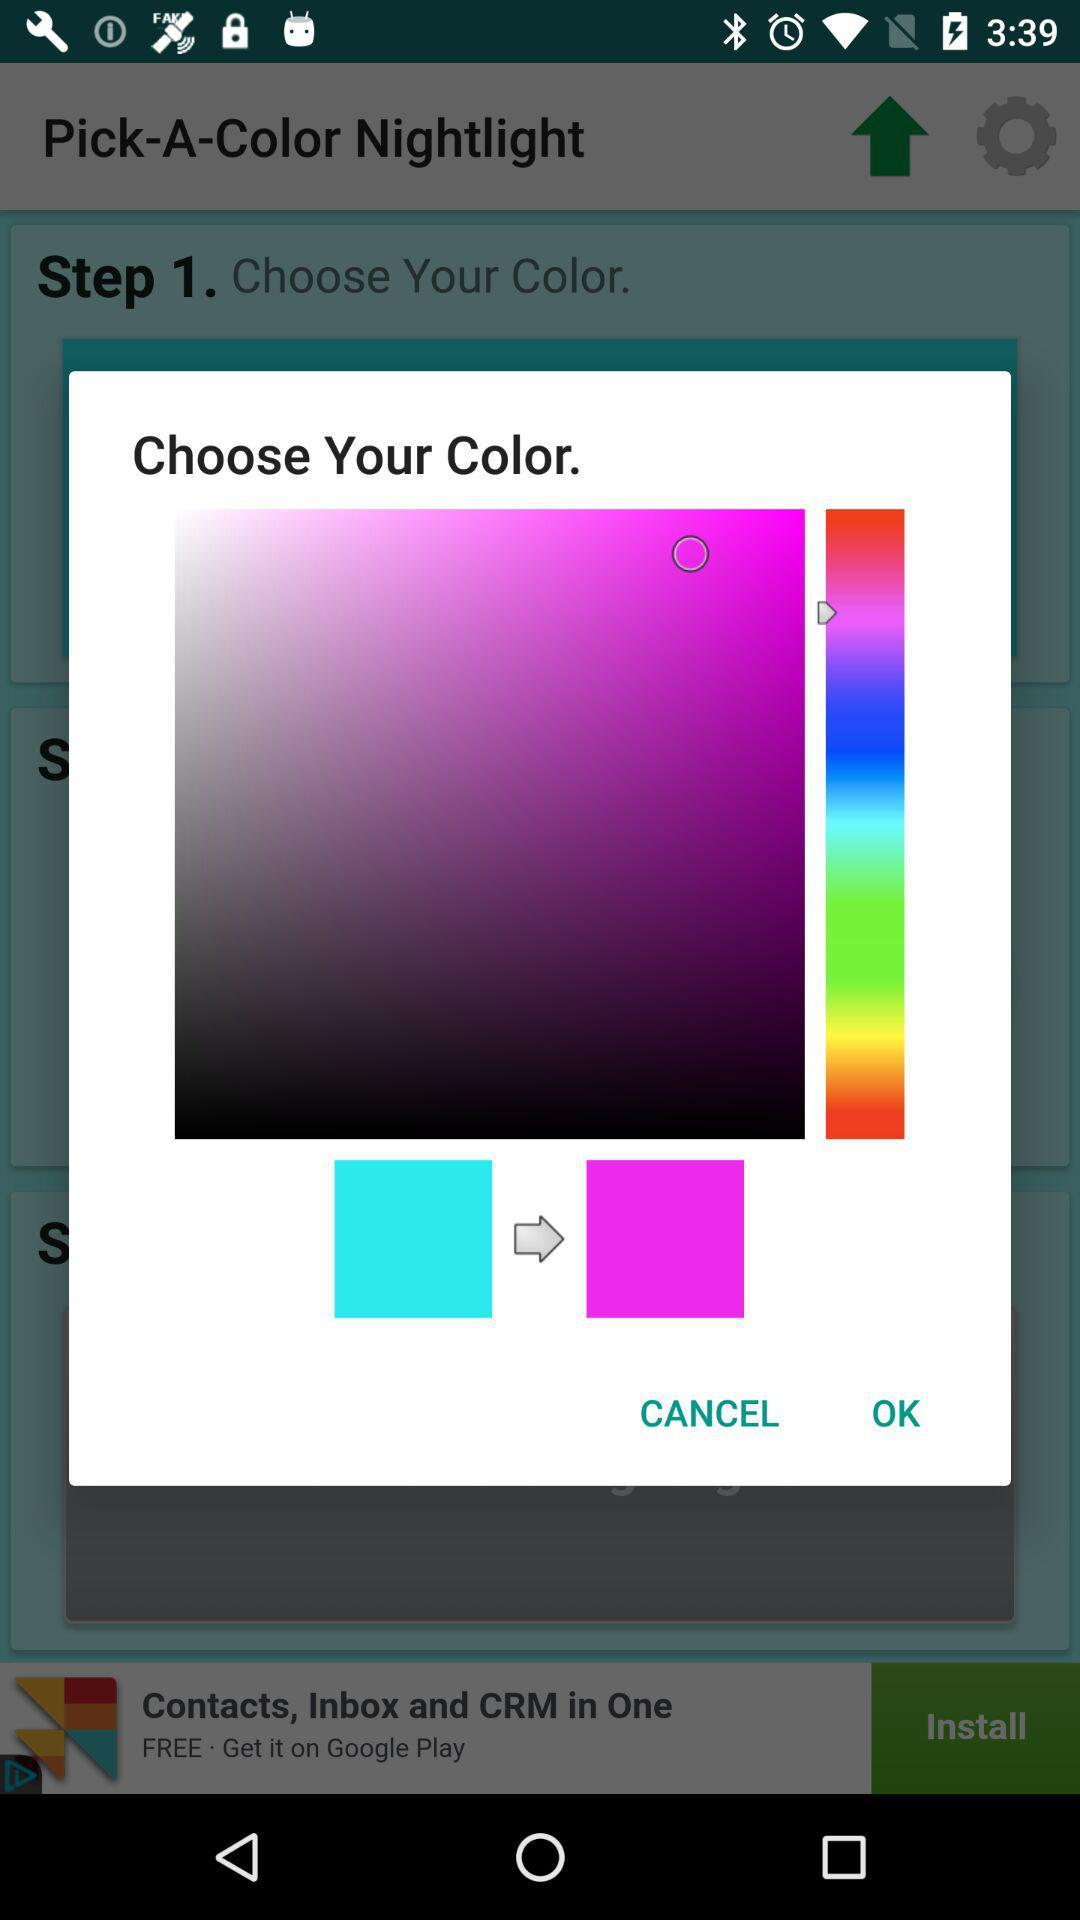What is the name of the application? The name of the application is "Pick-A-Color Nightlight". 